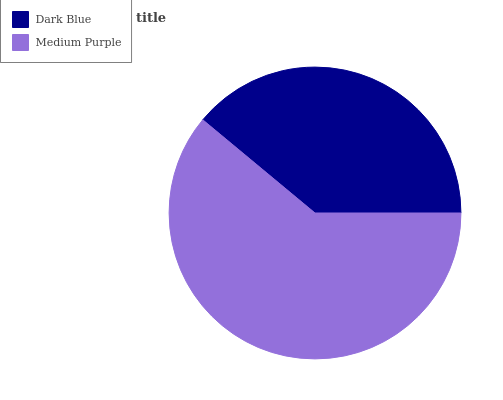Is Dark Blue the minimum?
Answer yes or no. Yes. Is Medium Purple the maximum?
Answer yes or no. Yes. Is Medium Purple the minimum?
Answer yes or no. No. Is Medium Purple greater than Dark Blue?
Answer yes or no. Yes. Is Dark Blue less than Medium Purple?
Answer yes or no. Yes. Is Dark Blue greater than Medium Purple?
Answer yes or no. No. Is Medium Purple less than Dark Blue?
Answer yes or no. No. Is Medium Purple the high median?
Answer yes or no. Yes. Is Dark Blue the low median?
Answer yes or no. Yes. Is Dark Blue the high median?
Answer yes or no. No. Is Medium Purple the low median?
Answer yes or no. No. 